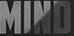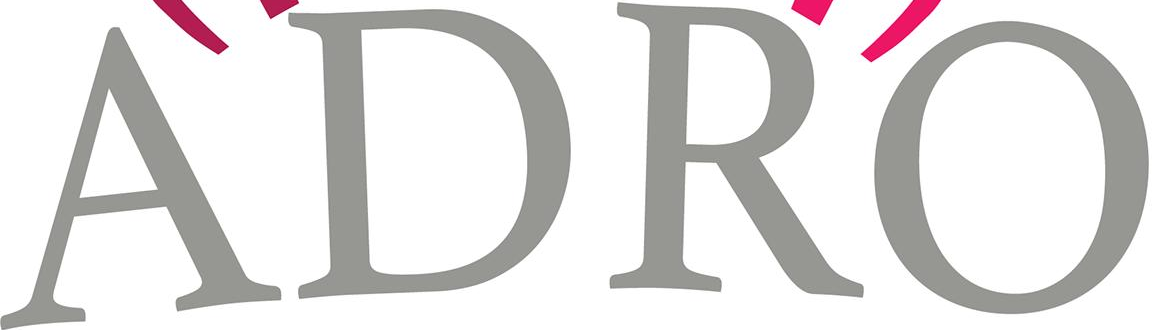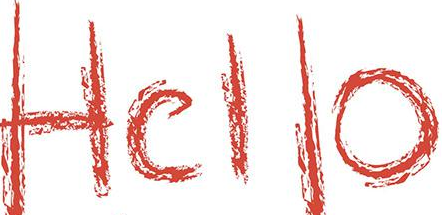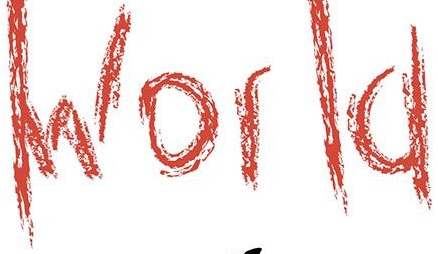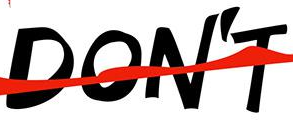What words are shown in these images in order, separated by a semicolon? MIND; ADRO; Hello; World; DON'T 